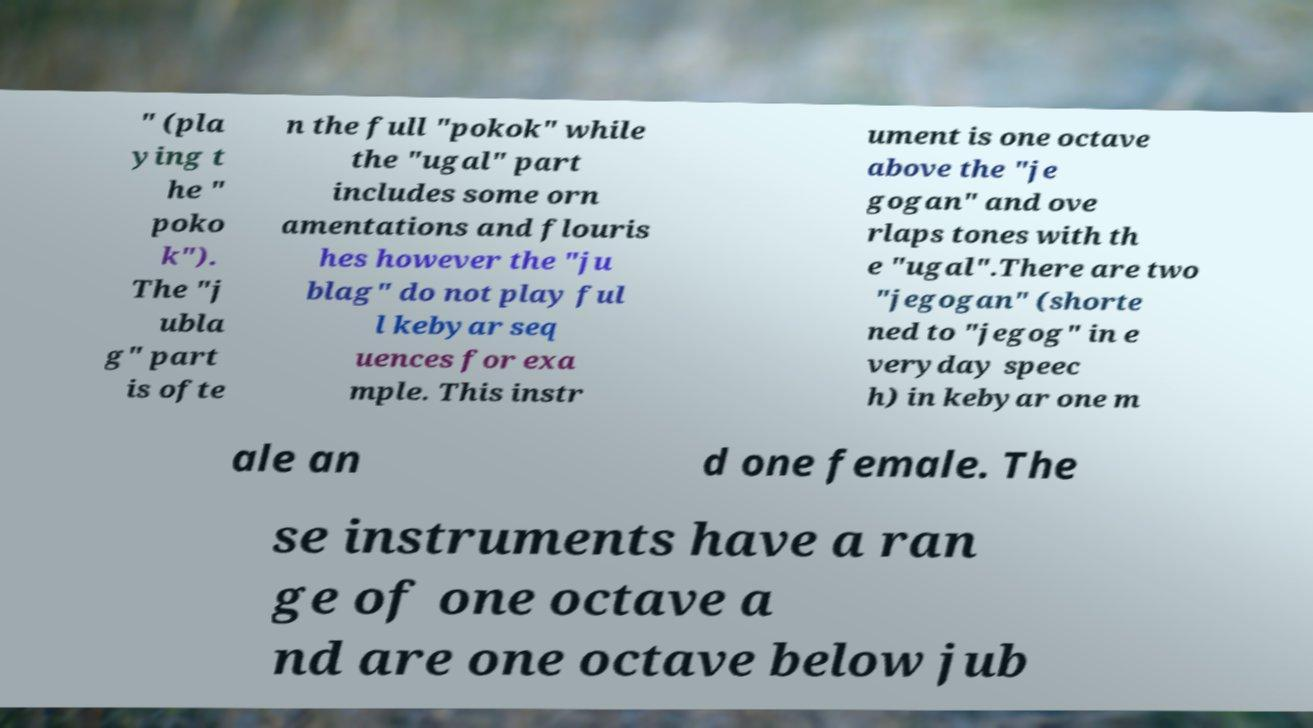What messages or text are displayed in this image? I need them in a readable, typed format. " (pla ying t he " poko k"). The "j ubla g" part is ofte n the full "pokok" while the "ugal" part includes some orn amentations and flouris hes however the "ju blag" do not play ful l kebyar seq uences for exa mple. This instr ument is one octave above the "je gogan" and ove rlaps tones with th e "ugal".There are two "jegogan" (shorte ned to "jegog" in e veryday speec h) in kebyar one m ale an d one female. The se instruments have a ran ge of one octave a nd are one octave below jub 